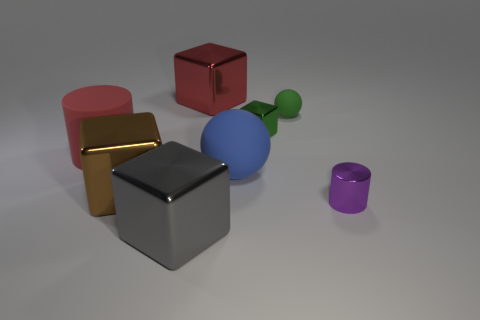Is the size of the metal cube that is in front of the metallic cylinder the same as the cylinder on the left side of the purple metallic cylinder?
Your answer should be very brief. Yes. Is the number of big blue matte things less than the number of tiny shiny things?
Ensure brevity in your answer.  Yes. How many metallic objects are either gray cubes or tiny green objects?
Your answer should be compact. 2. Is there a big blue rubber sphere to the left of the metal block behind the small sphere?
Give a very brief answer. No. Do the small green thing that is on the left side of the green rubber thing and the big red block have the same material?
Your answer should be compact. Yes. How many other things are there of the same color as the matte cylinder?
Ensure brevity in your answer.  1. Does the large cylinder have the same color as the small metal cylinder?
Provide a succinct answer. No. There is a shiny cube that is in front of the purple cylinder that is behind the gray shiny cube; what size is it?
Give a very brief answer. Large. Do the cylinder that is in front of the large brown metal block and the cube on the right side of the big red shiny thing have the same material?
Your response must be concise. Yes. Is the color of the big metal cube behind the red cylinder the same as the tiny sphere?
Provide a short and direct response. No. 